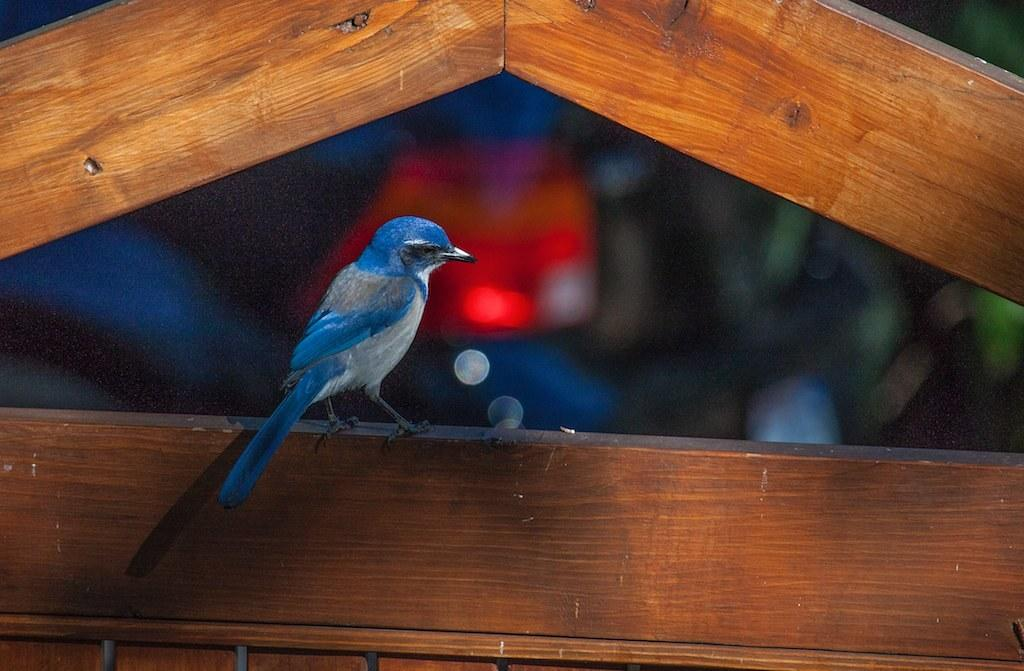What type of animal is in the image? There is a bird in the image. What is the bird standing on? The bird is on a wooden object. Can you describe the background of the image? The background of the image is not clear. What does the caption say about the bird in the image? There is no caption present in the image, so it is not possible to answer that question. 